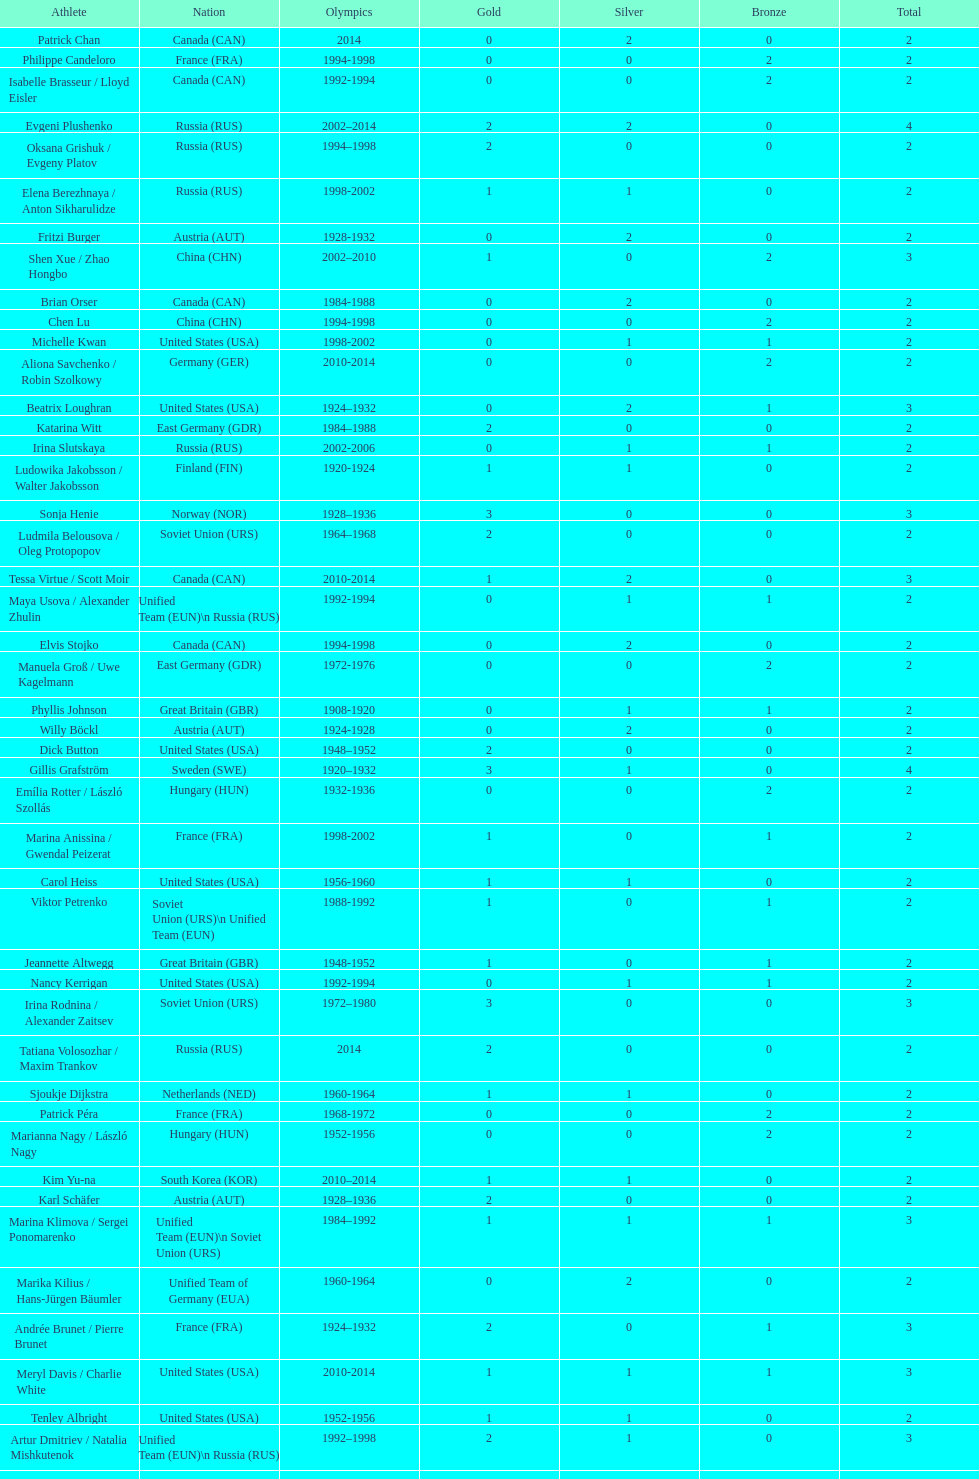How many total medals has the united states won in women's figure skating? 16. 